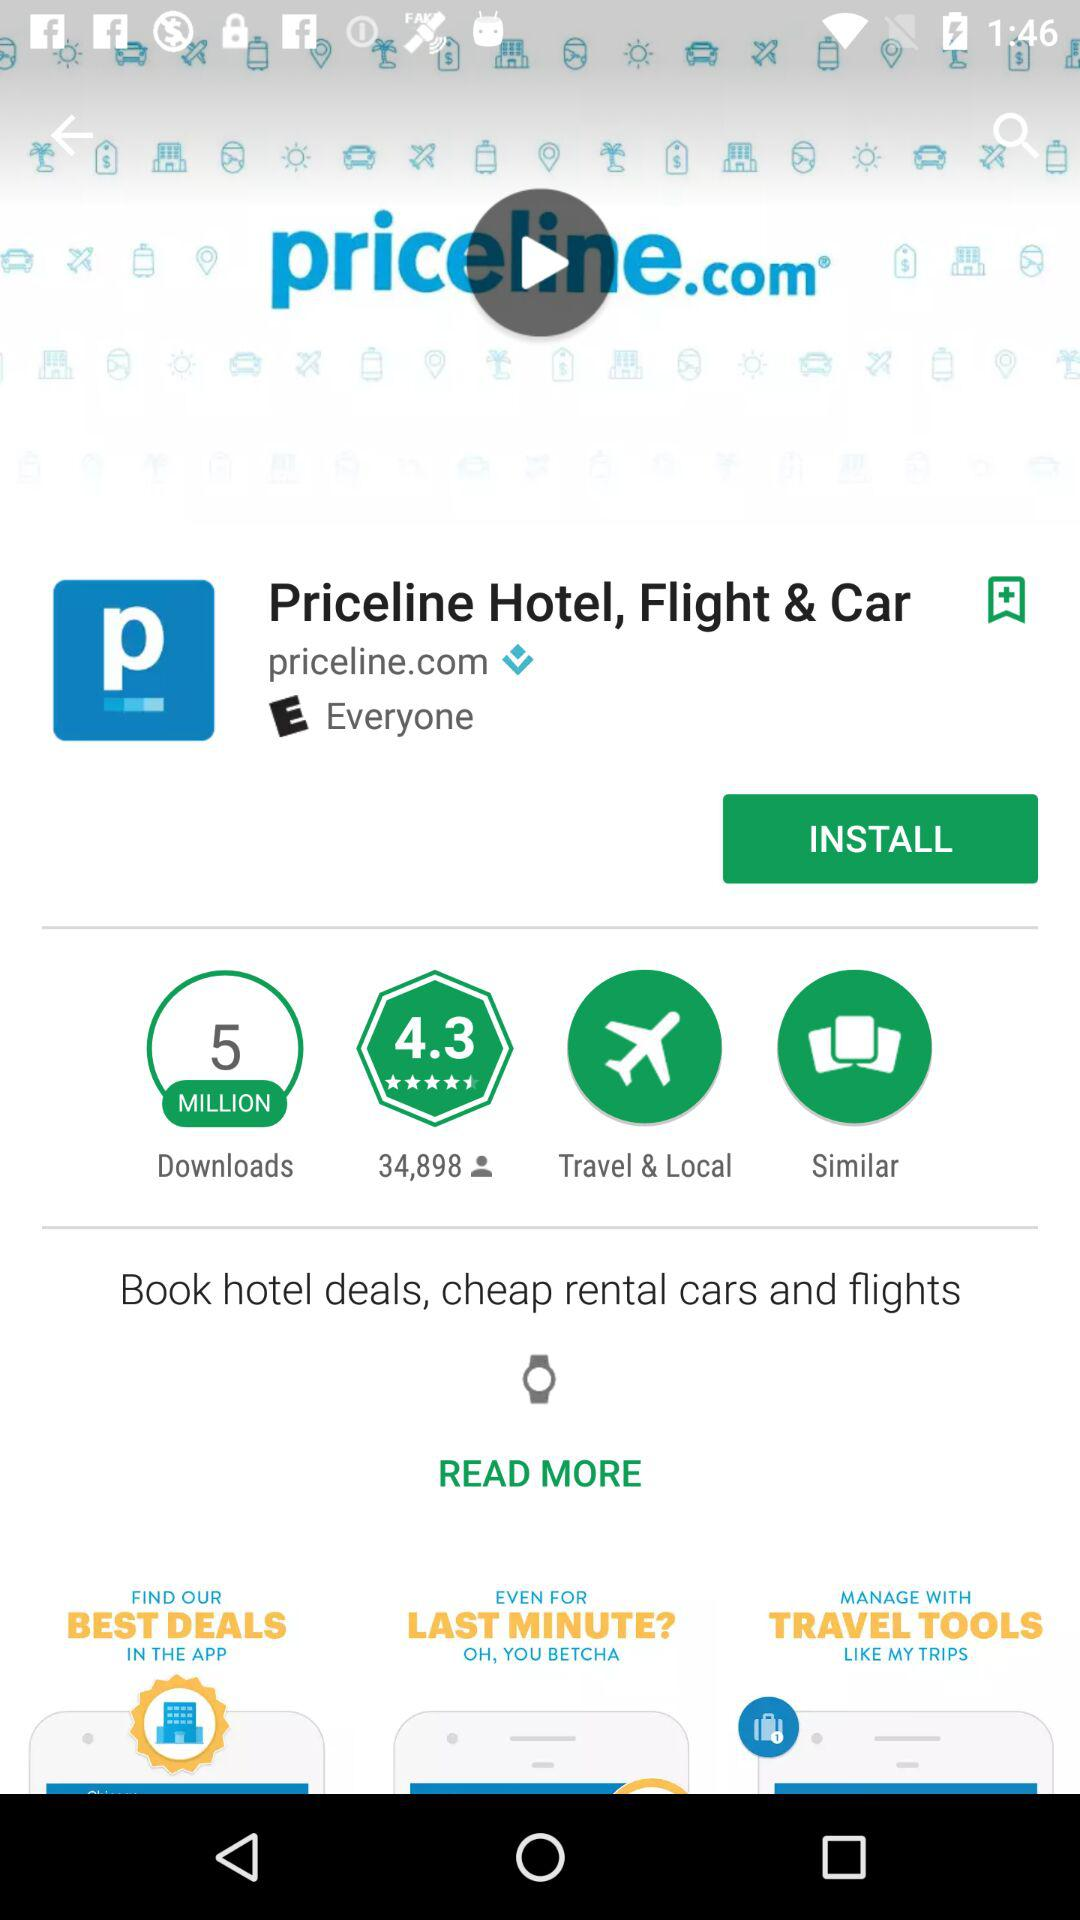What is the website of "Priceline Hotel, Flight & Car"? The website is priceline.com. 